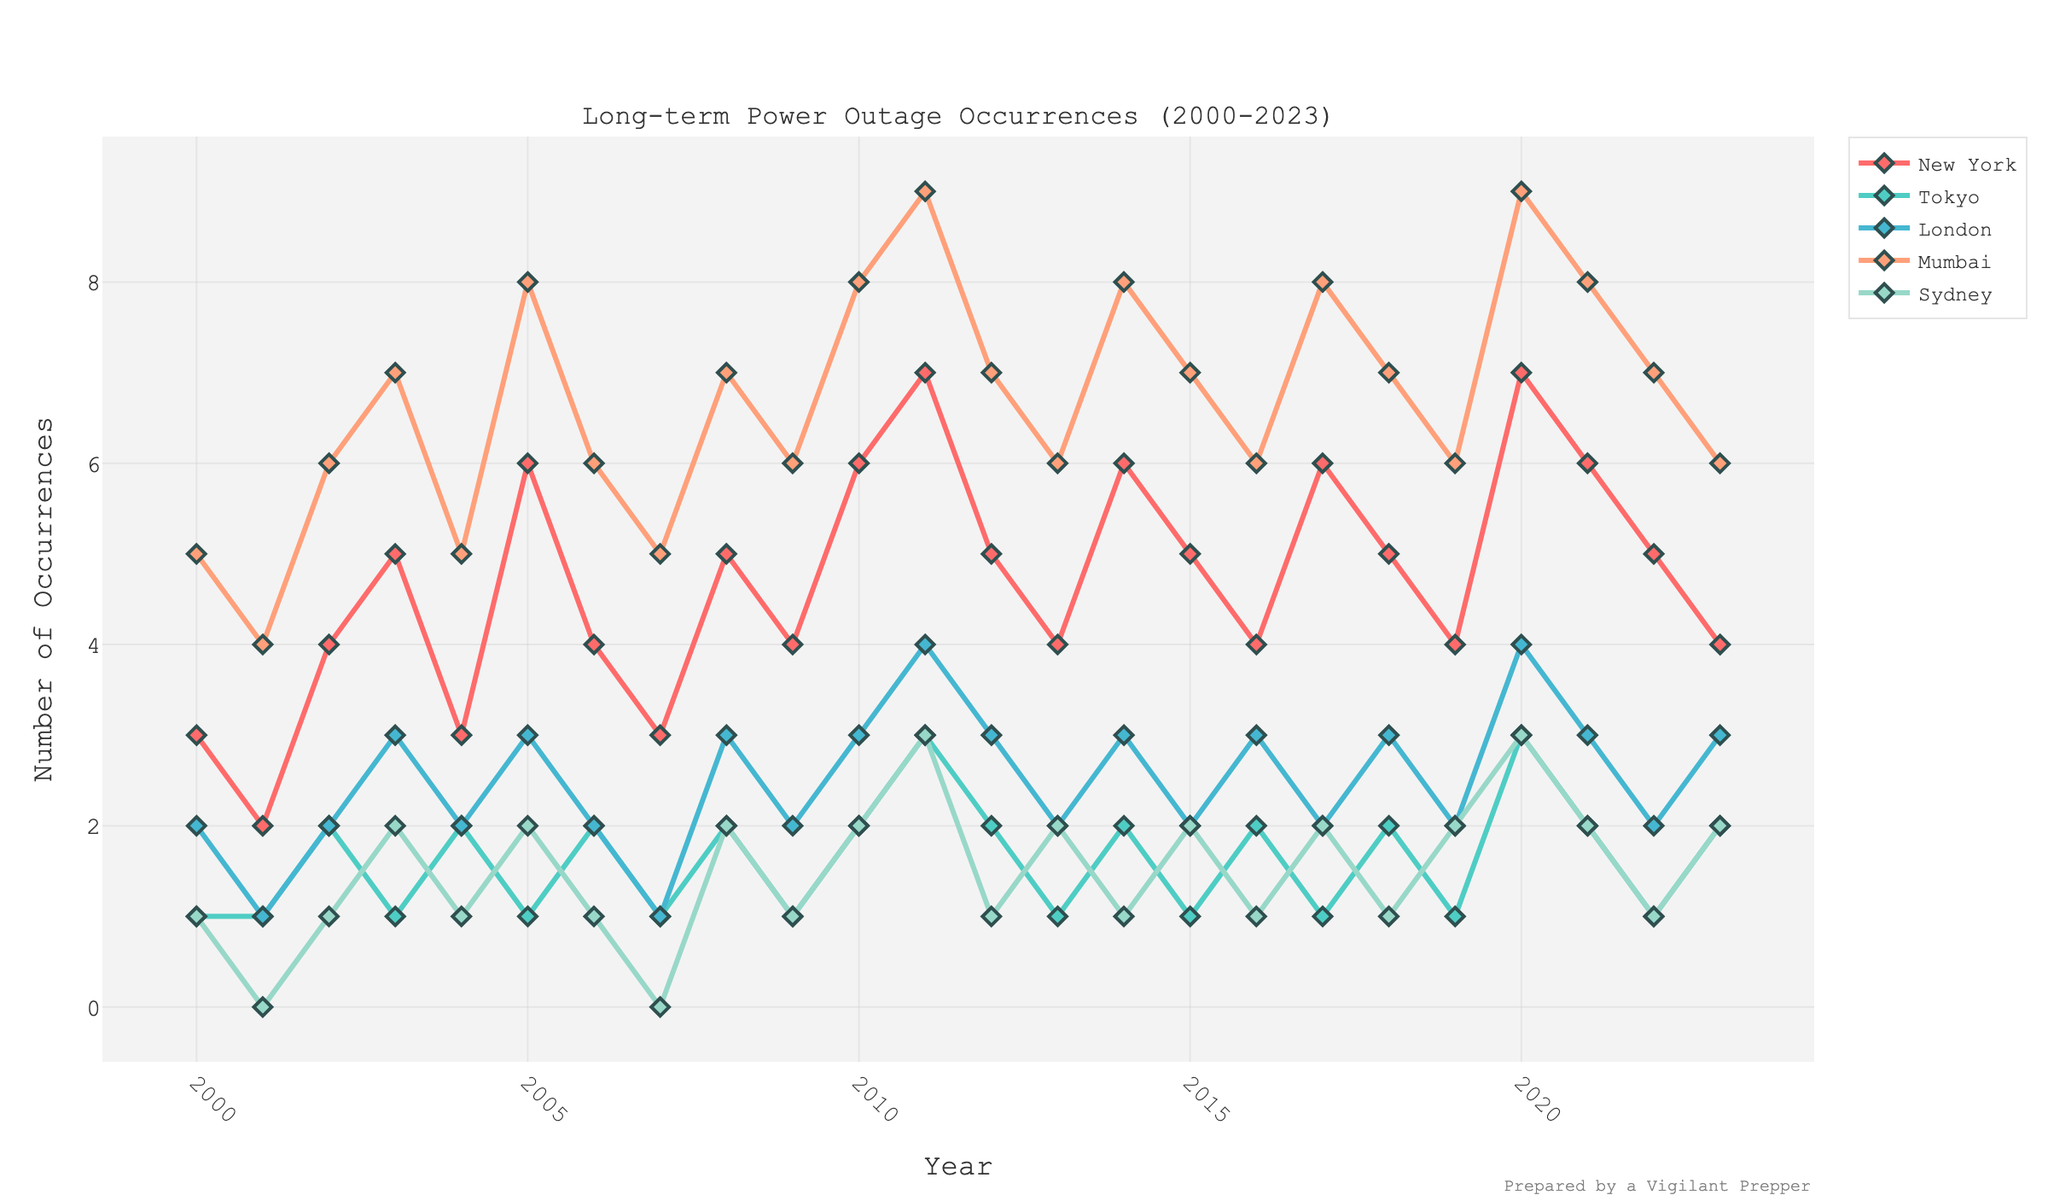Which city had the highest number of long-term power outages in 2023? From the figure, look at the data points for the year 2023 across all the cities. Notice that New York, Tokyo, London, Mumbai, and Sydney have the values of 4, 2, 3, 6, and 2 respectively. Mumbai has the highest number.
Answer: Mumbai How did the number of long-term power outages in New York change from 2000 to 2010? In the figure, find the data points for New York for the years 2000 and 2010. In 2000, it was 3, and in 2010, it increased to 6. To find the change, subtract the value in 2000 from the value in 2010: 6 - 3 = 3.
Answer: Increased by 3 Which city had the least number of long-term power outages in 2020? Look at the data points for the year 2020 across all cities. Notice that New York, Tokyo, London, Mumbai, and Sydney have the values of 7, 3, 4, 9, and 3 respectively. Tokyo and Sydney both have the least number of 3 occurrences.
Answer: Tokyo and Sydney Among London, Tokyo, and Sydney, which city showed the greatest variation in the number of long-term power outages from 2000 to 2023? Look at the figure to compare the lines representing London, Tokyo, and Sydney. Sydney's data points you can see a range from 0 to 3. Tokyo's range is from 1 to 3. London's range is from 1 to 4. Tokyo and Sydney showed slight variations in terms of lines but London had the highest change in values from 1 to 4.
Answer: London What was the average number of long-term power outages in Mumbai over the entire period? To find the average, add up all the occurrences for Mumbai over the years and divide by the number of years. (5+4+6+7+5+8+6+5+7+6+8+9+7+6+8+7+6+8+7+6+9+8+7+6)/24 = 6.458333
Answer: Approximately 6.46 Which year had the maximum total of long-term power outages across all the cities? Sum the data points for each year and find which year has the highest total. E.g., for 2003: 5+1+3+7+2 = 18. Continue this for each year and compare. The year 2020 will have the maximum total as summing up: 7 + 3 + 4 + 9 + 3 = 26.
Answer: 2020 Between 2010 and 2020, which city had the most consistent number of long-term power outages? Look at the lines representing the cities between 2010 and 2020. The city with the least variation in its line is most consistent. Tokyo’s line is relatively flat ranging from 1 to 3. Therefore, Tokyo had the most consistent outage counts.
Answer: Tokyo Which city had a sudden increase in long-term power outages between 2005 and 2006, and how much was the increase? Identify the steepest increase between these years. For New York, 2005 was 6 and 2006 was 4 (decrease). For Tokyo, 2005 was 1 and 2006 was 2 (increase of 1). For London, 2005 was 3 and 2006 was 2 (decrease). For Mumbai, 2005 was 8 and 2006 was 6 (decrease). For Sydney, 2005 was 2 and 2006 was 1 (decrease). Hence, Tokyo showed an increase by 1 occurrence.
Answer: Tokyo, increased by 1 